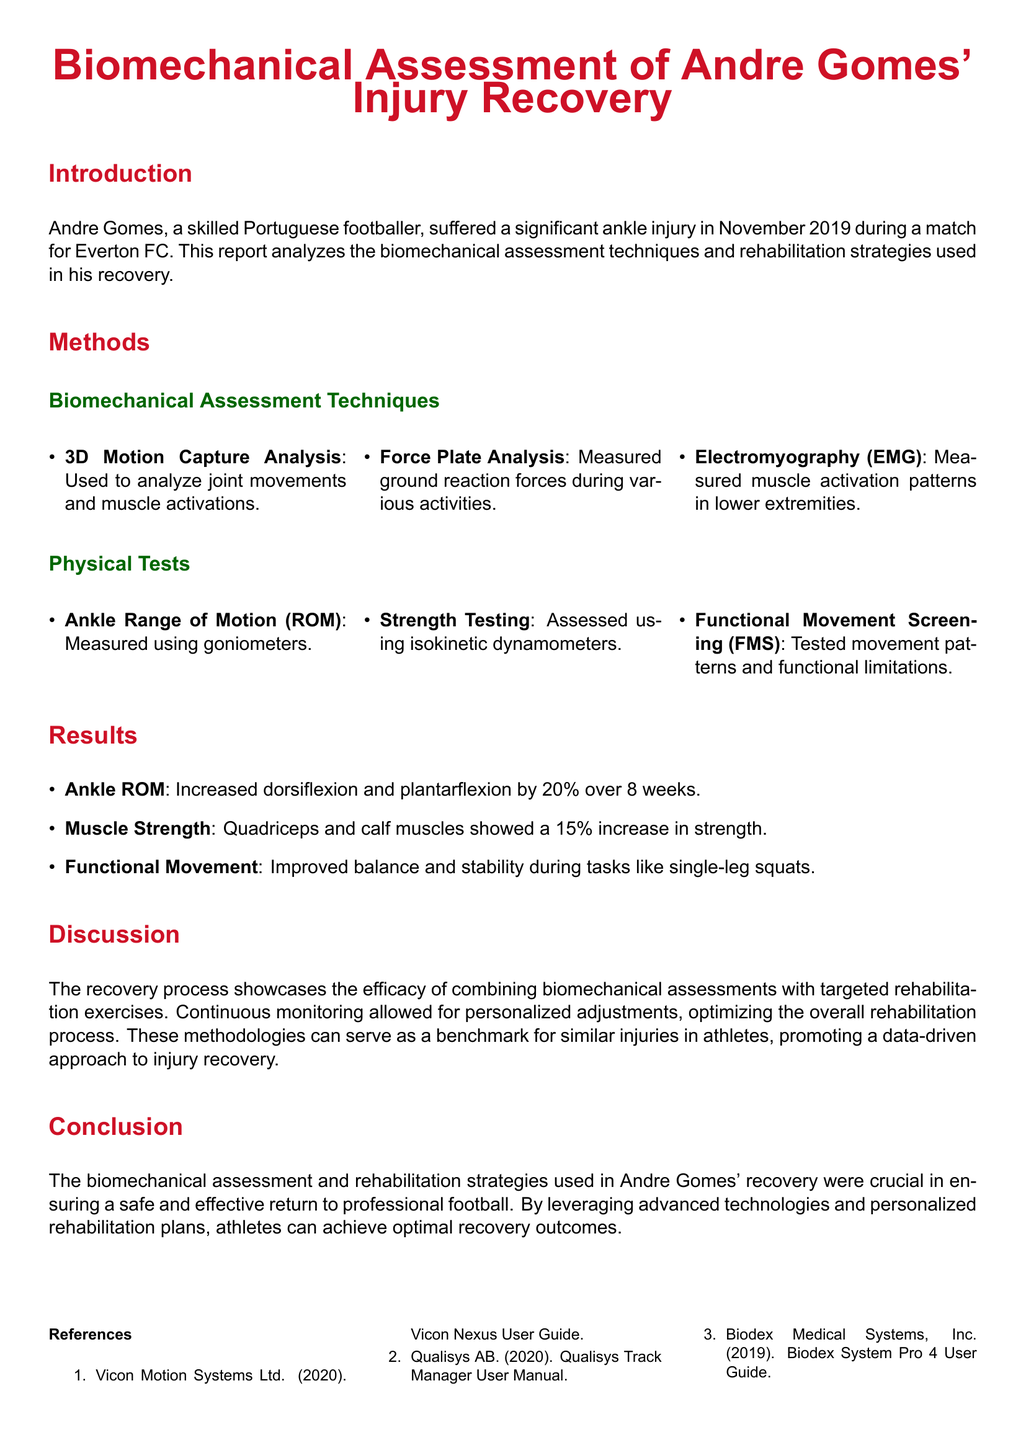What injury did Andre Gomes suffer? Andre Gomes suffered a significant ankle injury during a match for Everton FC.
Answer: ankle injury In which month and year did Andre Gomes sustain his injury? The injury occurred in November 2019.
Answer: November 2019 What technology was used for analyzing joint movements? 3D motion capture analysis was used to analyze joint movements.
Answer: 3D motion capture analysis By what percentage did ankle range of motion increase over 8 weeks? Ankle ROM increased by 20% over 8 weeks.
Answer: 20% What was the percentage increase in strength for quadriceps and calf muscles? Quadriceps and calf muscles showed a 15% increase in strength.
Answer: 15% What is the primary focus of the report's discussion section? The discussion focuses on the efficacy of combining biomechanical assessments with targeted rehabilitation exercises.
Answer: efficacy of combining biomechanical assessments Which method was used to measure muscle activation patterns? Electromyography (EMG) was used to measure muscle activation patterns.
Answer: Electromyography (EMG) What is the conclusion regarding the rehabilitation strategies used? The conclusion emphasizes the importance of advanced technologies and personalized rehabilitation plans.
Answer: advanced technologies and personalized rehabilitation plans What assessment measured ground reaction forces? Force plate analysis measured ground reaction forces.
Answer: Force plate analysis 